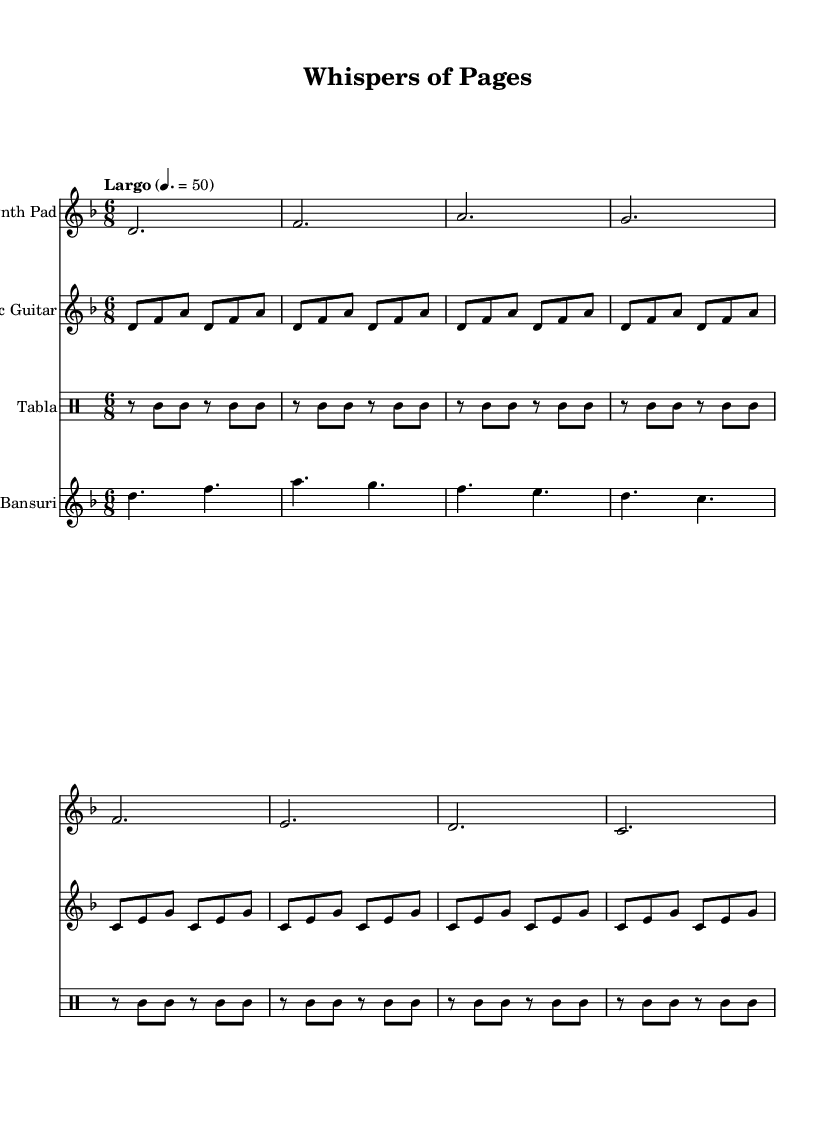What is the key signature of this music? The key signature is two flats, indicating D minor. This can be determined from the beginning of the score where the key signature indicators are displayed, showing the specific arrangement of flats.
Answer: D minor What is the time signature of this music? The time signature is 6/8, which is indicated at the start of the piece. This means there are six eighth notes in each measure, giving the music a compound duple feel.
Answer: 6/8 What is the tempo marking for this piece? The tempo marking is Largo, noted at the beginning, which generally indicates a slow pace. The specified beats per minute is 50, allowing an understanding of how fast or slow the piece should be played.
Answer: Largo 50 How many staff instruments are present in the score? There are four distinct staff instruments indicated: Synth Pad, Acoustic Guitar, Tabla, and Bansuri. This information is found in the score title headers under the staff notation, clearly denoting different instruments.
Answer: 4 Which instrument plays the first note of the piece? The first note of the piece is played by the Synth Pad, as indicated in the first staff of the score which presents the melody starting with D. This is observable in the notation sequence at the beginning.
Answer: Synth Pad What rhythmic pattern is used by the Tabla? The Tabla uses a simple rhythmic pattern consisting of two rhythmic rests followed by repeated eighth notes, creating a consistent beat. This can be analyzed within the rhythmic section of the drum staff.
Answer: r8 c c r c c What types of musical elements characterize the Acoustic Guitar part? The Acoustic Guitar part features arpeggiated chords that unfold over multiple measures, indicated by repeating patterns of rhythms and notes which create a harmonic texture typical for fusion music. This can be detected by examining the rhythmic and note structure of the guitar staff.
Answer: Arpeggiated chords 